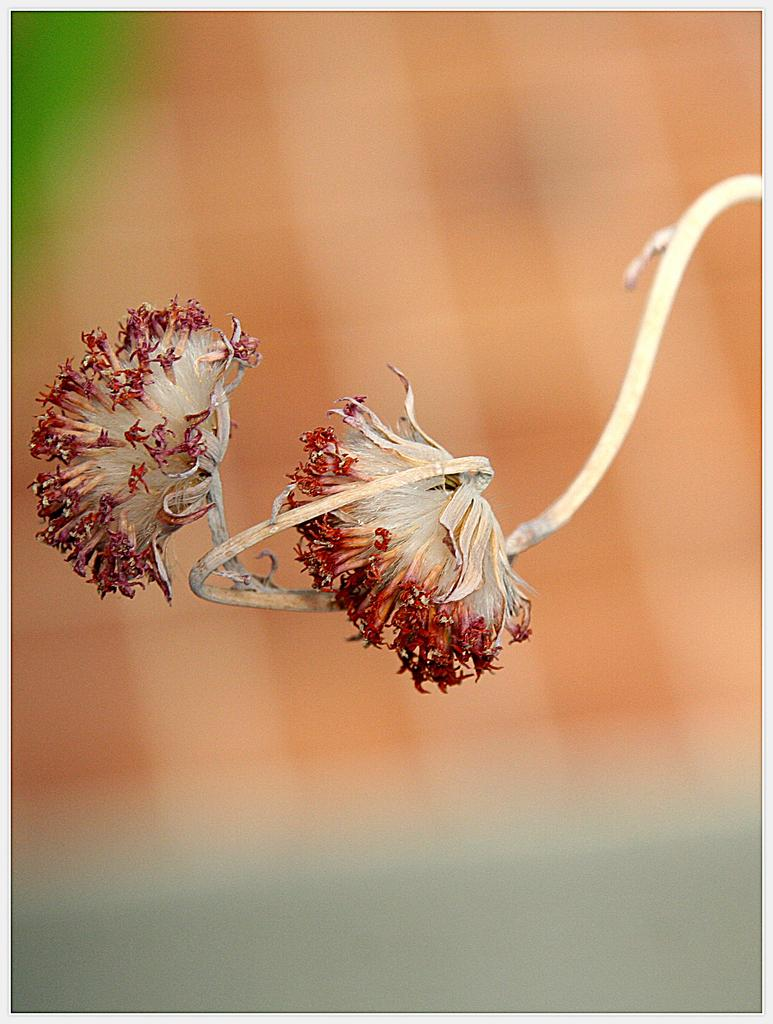How many flowers are present in the image? There are two flowers in the image. What can be observed about the background of the image? The background of the image is blurred. Is there a surprise element hidden within the water in the image? There is no water or any hidden elements mentioned in the image; it only features two flowers with a blurred background. 